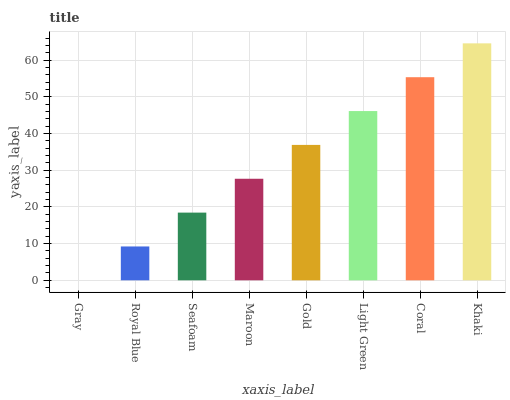Is Gray the minimum?
Answer yes or no. Yes. Is Khaki the maximum?
Answer yes or no. Yes. Is Royal Blue the minimum?
Answer yes or no. No. Is Royal Blue the maximum?
Answer yes or no. No. Is Royal Blue greater than Gray?
Answer yes or no. Yes. Is Gray less than Royal Blue?
Answer yes or no. Yes. Is Gray greater than Royal Blue?
Answer yes or no. No. Is Royal Blue less than Gray?
Answer yes or no. No. Is Gold the high median?
Answer yes or no. Yes. Is Maroon the low median?
Answer yes or no. Yes. Is Seafoam the high median?
Answer yes or no. No. Is Coral the low median?
Answer yes or no. No. 